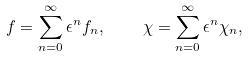Convert formula to latex. <formula><loc_0><loc_0><loc_500><loc_500>f = \sum _ { n = 0 } ^ { \infty } \epsilon ^ { n } f _ { n } , \quad \chi = \sum _ { n = 0 } ^ { \infty } \epsilon ^ { n } \chi _ { n } ,</formula> 